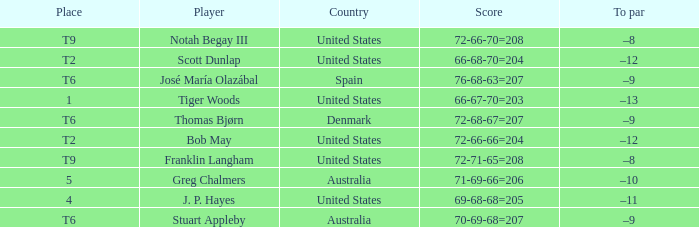What is the country of the player with a t6 place? Australia, Denmark, Spain. Can you give me this table as a dict? {'header': ['Place', 'Player', 'Country', 'Score', 'To par'], 'rows': [['T9', 'Notah Begay III', 'United States', '72-66-70=208', '–8'], ['T2', 'Scott Dunlap', 'United States', '66-68-70=204', '–12'], ['T6', 'José María Olazábal', 'Spain', '76-68-63=207', '–9'], ['1', 'Tiger Woods', 'United States', '66-67-70=203', '–13'], ['T6', 'Thomas Bjørn', 'Denmark', '72-68-67=207', '–9'], ['T2', 'Bob May', 'United States', '72-66-66=204', '–12'], ['T9', 'Franklin Langham', 'United States', '72-71-65=208', '–8'], ['5', 'Greg Chalmers', 'Australia', '71-69-66=206', '–10'], ['4', 'J. P. Hayes', 'United States', '69-68-68=205', '–11'], ['T6', 'Stuart Appleby', 'Australia', '70-69-68=207', '–9']]} 